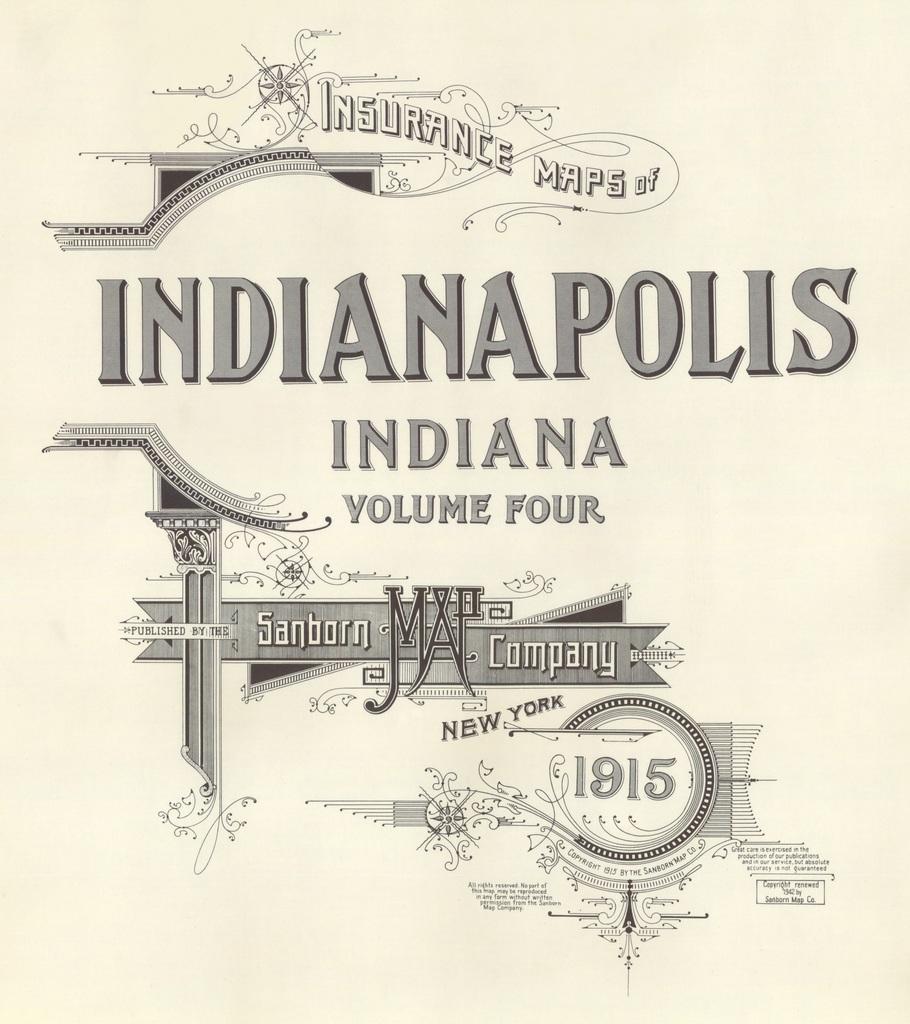What city is this?
Offer a very short reply. Indianapolis. 